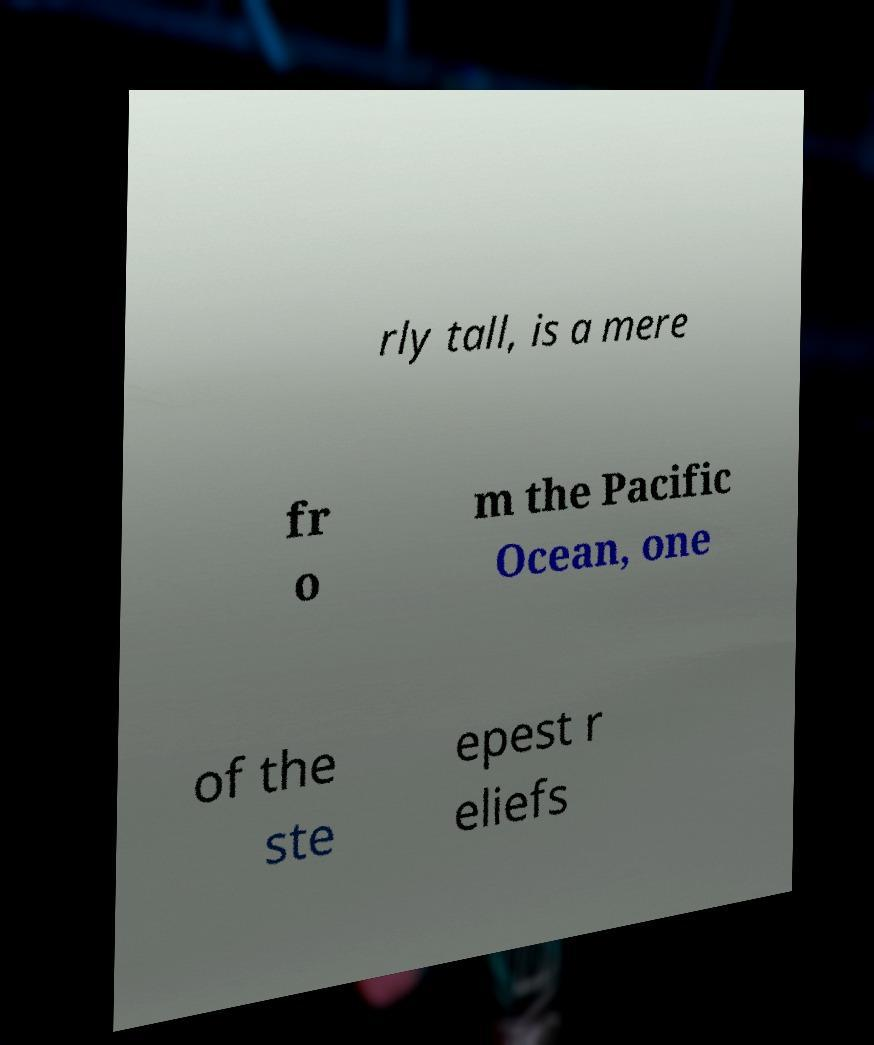Could you extract and type out the text from this image? rly tall, is a mere fr o m the Pacific Ocean, one of the ste epest r eliefs 